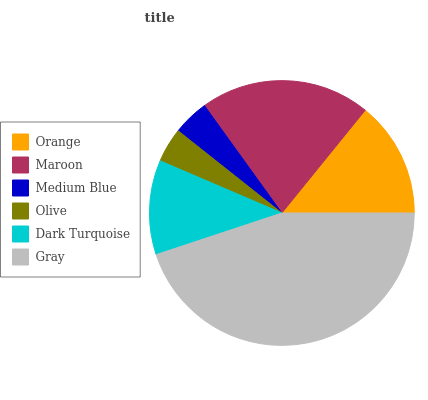Is Olive the minimum?
Answer yes or no. Yes. Is Gray the maximum?
Answer yes or no. Yes. Is Maroon the minimum?
Answer yes or no. No. Is Maroon the maximum?
Answer yes or no. No. Is Maroon greater than Orange?
Answer yes or no. Yes. Is Orange less than Maroon?
Answer yes or no. Yes. Is Orange greater than Maroon?
Answer yes or no. No. Is Maroon less than Orange?
Answer yes or no. No. Is Orange the high median?
Answer yes or no. Yes. Is Dark Turquoise the low median?
Answer yes or no. Yes. Is Gray the high median?
Answer yes or no. No. Is Orange the low median?
Answer yes or no. No. 